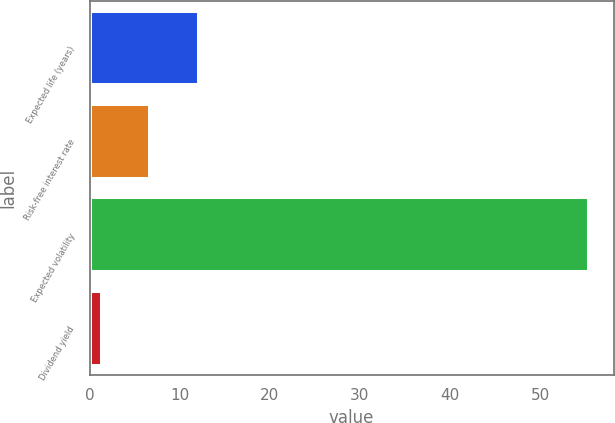Convert chart. <chart><loc_0><loc_0><loc_500><loc_500><bar_chart><fcel>Expected life (years)<fcel>Risk-free interest rate<fcel>Expected volatility<fcel>Dividend yield<nl><fcel>12.12<fcel>6.71<fcel>55.39<fcel>1.3<nl></chart> 